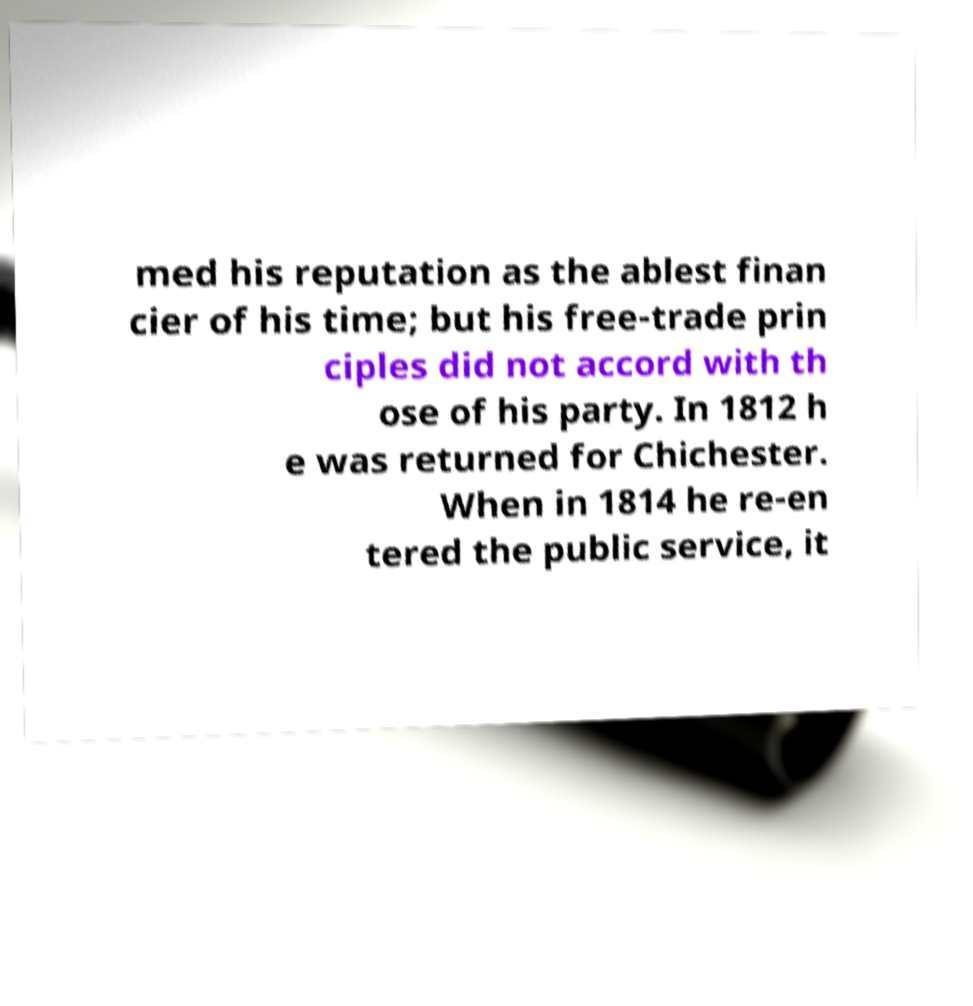What messages or text are displayed in this image? I need them in a readable, typed format. med his reputation as the ablest finan cier of his time; but his free-trade prin ciples did not accord with th ose of his party. In 1812 h e was returned for Chichester. When in 1814 he re-en tered the public service, it 